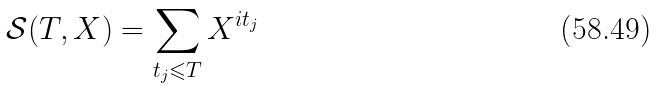<formula> <loc_0><loc_0><loc_500><loc_500>\mathcal { S } ( T , X ) = \sum _ { t _ { j } \leqslant T } X ^ { i t _ { j } }</formula> 